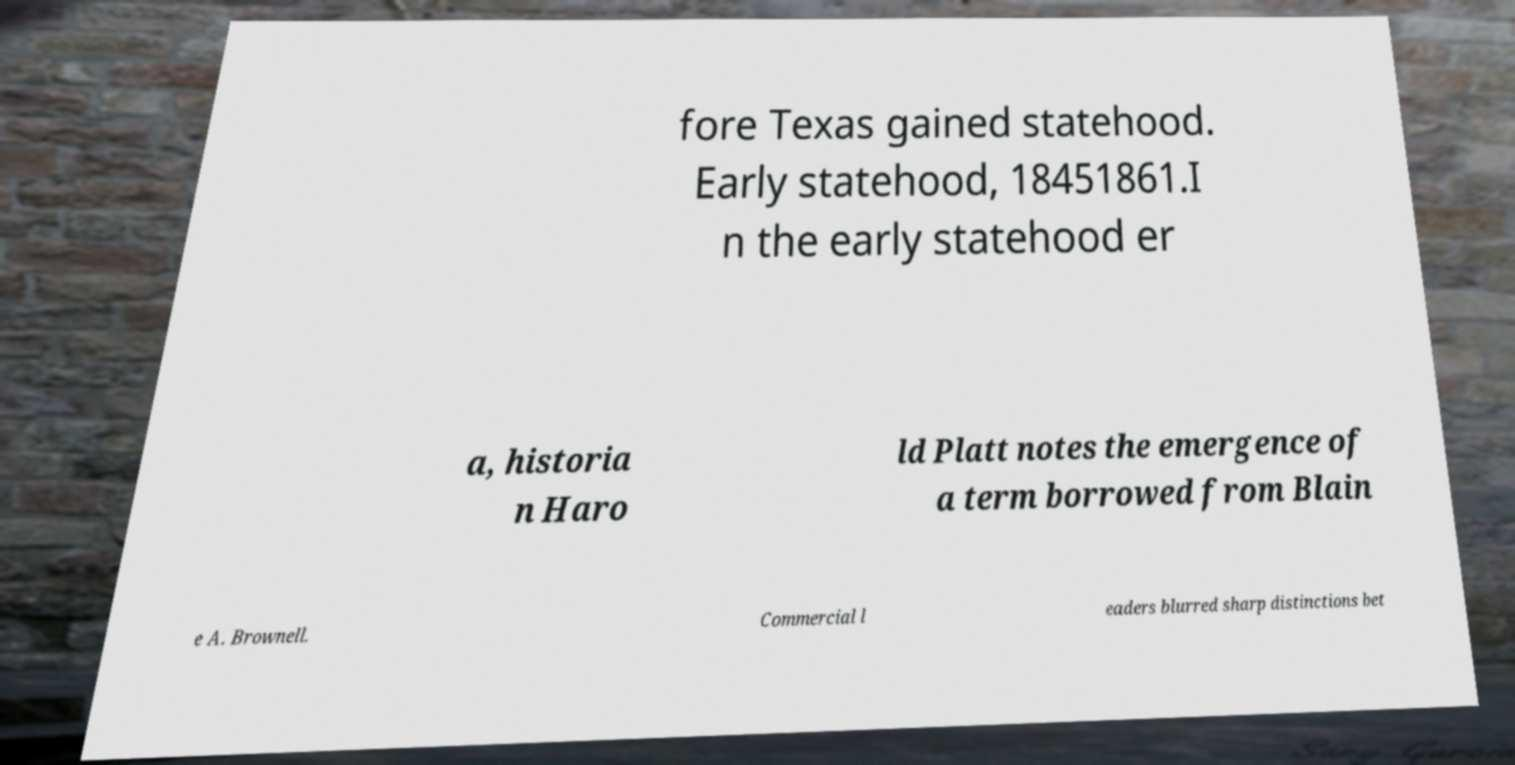There's text embedded in this image that I need extracted. Can you transcribe it verbatim? fore Texas gained statehood. Early statehood, 18451861.I n the early statehood er a, historia n Haro ld Platt notes the emergence of a term borrowed from Blain e A. Brownell. Commercial l eaders blurred sharp distinctions bet 